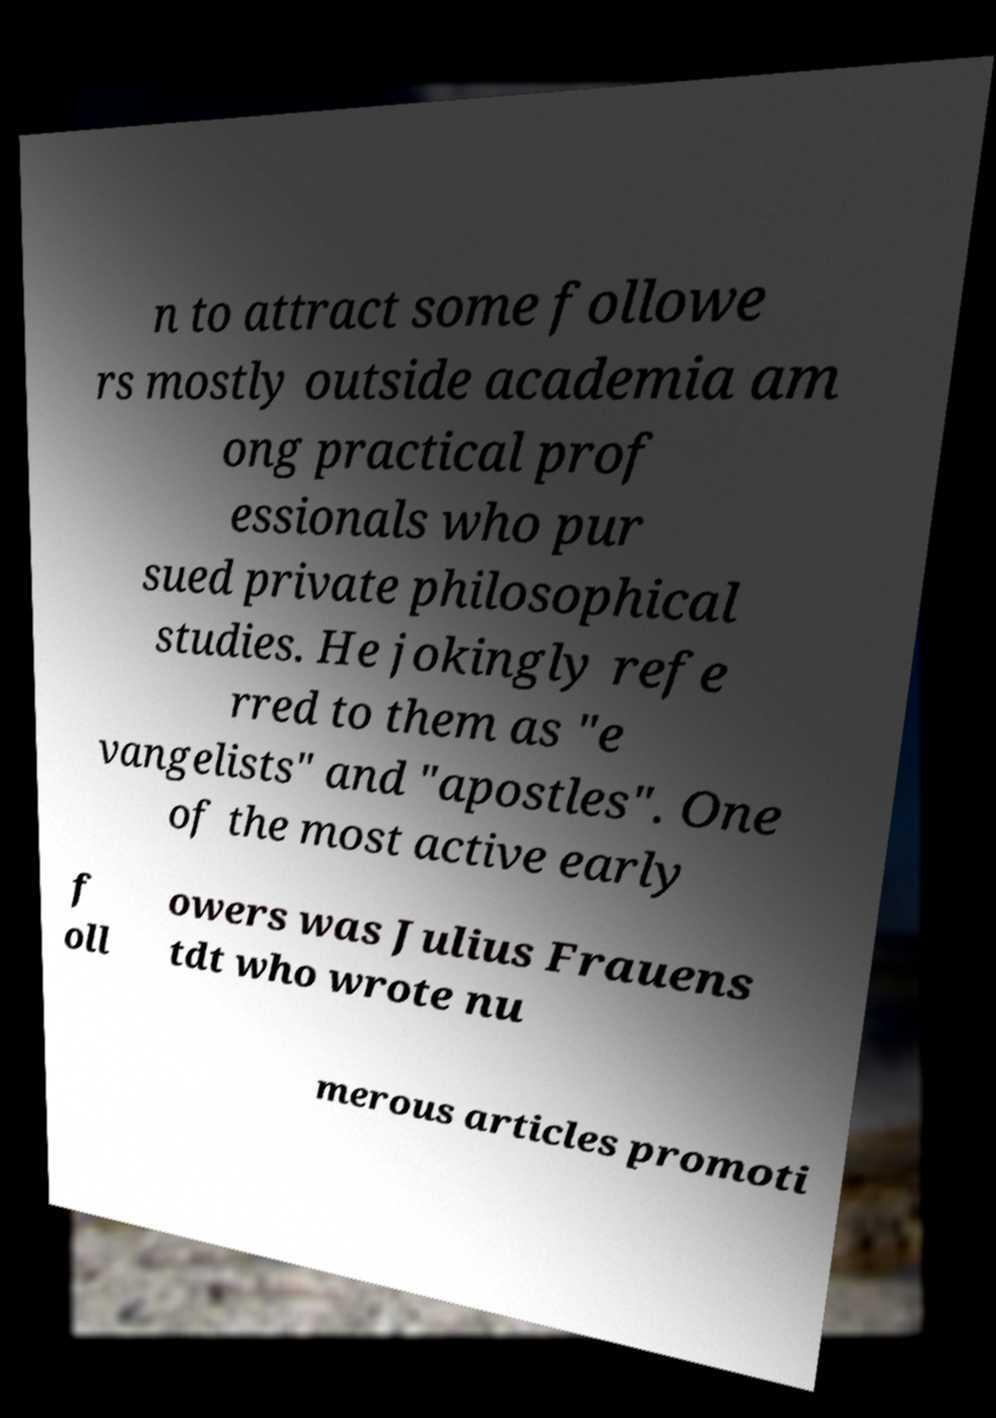For documentation purposes, I need the text within this image transcribed. Could you provide that? n to attract some followe rs mostly outside academia am ong practical prof essionals who pur sued private philosophical studies. He jokingly refe rred to them as "e vangelists" and "apostles". One of the most active early f oll owers was Julius Frauens tdt who wrote nu merous articles promoti 